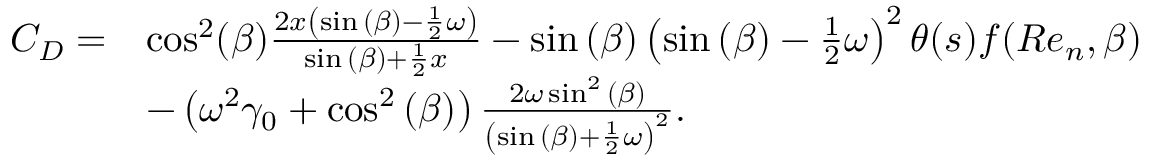Convert formula to latex. <formula><loc_0><loc_0><loc_500><loc_500>\begin{array} { r l } { C _ { D } = } & { \cos ^ { 2 } ( \beta ) \frac { 2 x \left ( \sin { ( \beta ) } - \frac { 1 } { 2 } \omega \right ) } { \sin { ( \beta ) } + \frac { 1 } { 2 } x } - \sin { ( \beta ) } \left ( \sin { ( \beta ) } - \frac { 1 } { 2 } \omega \right ) ^ { 2 } \theta ( s ) f ( R e _ { n } , \beta ) } \\ & { - \left ( \omega ^ { 2 } \gamma _ { 0 } + \cos ^ { 2 } { ( \beta ) } \right ) \frac { 2 \omega \sin ^ { 2 } { ( \beta ) } } { \left ( \sin { ( \beta ) } + \frac { 1 } { 2 } \omega \right ) ^ { 2 } } . } \end{array}</formula> 